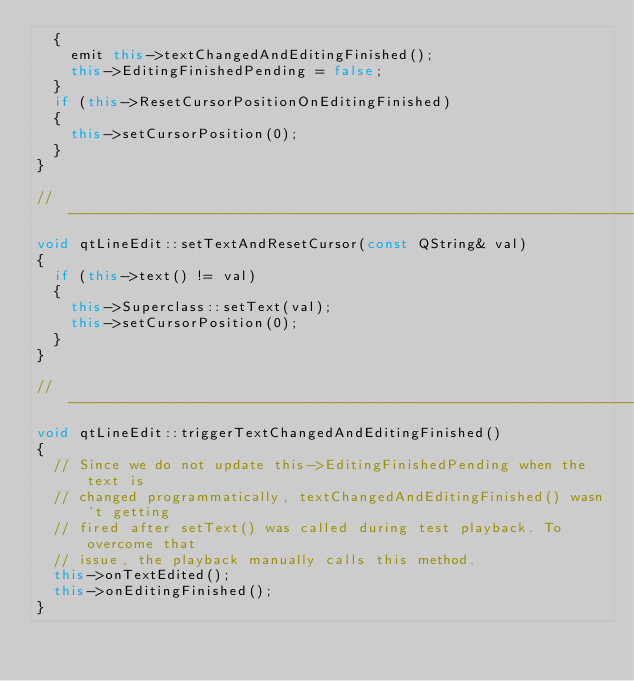Convert code to text. <code><loc_0><loc_0><loc_500><loc_500><_C++_>  {
    emit this->textChangedAndEditingFinished();
    this->EditingFinishedPending = false;
  }
  if (this->ResetCursorPositionOnEditingFinished)
  {
    this->setCursorPosition(0);
  }
}

//-----------------------------------------------------------------------------
void qtLineEdit::setTextAndResetCursor(const QString& val)
{
  if (this->text() != val)
  {
    this->Superclass::setText(val);
    this->setCursorPosition(0);
  }
}

//-----------------------------------------------------------------------------
void qtLineEdit::triggerTextChangedAndEditingFinished()
{
  // Since we do not update this->EditingFinishedPending when the text is
  // changed programmatically, textChangedAndEditingFinished() wasn't getting
  // fired after setText() was called during test playback. To overcome that
  // issue, the playback manually calls this method.
  this->onTextEdited();
  this->onEditingFinished();
}
</code> 